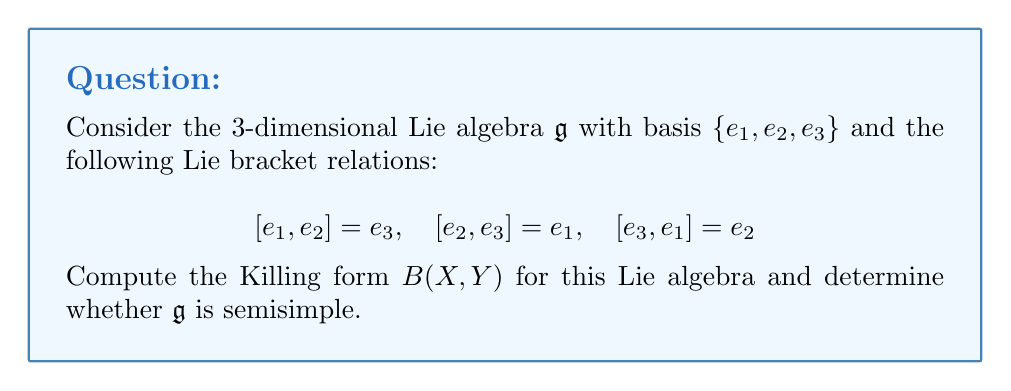Can you answer this question? To solve this problem, we'll follow these steps:

1) Recall that the Killing form is defined as $B(X,Y) = \text{tr}(\text{ad}_X \circ \text{ad}_Y)$, where $\text{ad}_X(Z) = [X,Z]$.

2) First, we need to compute the adjoint representations for each basis element:

   For $e_1$: $\text{ad}_{e_1}(e_2) = [e_1, e_2] = e_3$, $\text{ad}_{e_1}(e_3) = [e_1, e_3] = -e_2$
   
   For $e_2$: $\text{ad}_{e_2}(e_3) = [e_2, e_3] = e_1$, $\text{ad}_{e_2}(e_1) = [e_2, e_1] = -e_3$
   
   For $e_3$: $\text{ad}_{e_3}(e_1) = [e_3, e_1] = e_2$, $\text{ad}_{e_3}(e_2) = [e_3, e_2] = -e_1$

3) We can represent these as matrices:

   $$\text{ad}_{e_1} = \begin{pmatrix} 0 & 0 & 0 \\ 0 & 0 & -1 \\ 0 & 1 & 0 \end{pmatrix}$$
   
   $$\text{ad}_{e_2} = \begin{pmatrix} 0 & 0 & 1 \\ 0 & 0 & 0 \\ -1 & 0 & 0 \end{pmatrix}$$
   
   $$\text{ad}_{e_3} = \begin{pmatrix} 0 & -1 & 0 \\ 1 & 0 & 0 \\ 0 & 0 & 0 \end{pmatrix}$$

4) Now, we compute $B(e_i, e_j)$ for all $i,j \in \{1,2,3\}$:

   $B(e_1, e_1) = \text{tr}(\text{ad}_{e_1} \circ \text{ad}_{e_1}) = -2$
   
   $B(e_2, e_2) = \text{tr}(\text{ad}_{e_2} \circ \text{ad}_{e_2}) = -2$
   
   $B(e_3, e_3) = \text{tr}(\text{ad}_{e_3} \circ \text{ad}_{e_3}) = -2$
   
   $B(e_1, e_2) = B(e_2, e_1) = \text{tr}(\text{ad}_{e_1} \circ \text{ad}_{e_2}) = 0$
   
   $B(e_1, e_3) = B(e_3, e_1) = \text{tr}(\text{ad}_{e_1} \circ \text{ad}_{e_3}) = 0$
   
   $B(e_2, e_3) = B(e_3, e_2) = \text{tr}(\text{ad}_{e_2} \circ \text{ad}_{e_3}) = 0$

5) Therefore, the Killing form can be represented as the matrix:

   $$B = \begin{pmatrix} -2 & 0 & 0 \\ 0 & -2 & 0 \\ 0 & 0 & -2 \end{pmatrix}$$

6) To determine if $\mathfrak{g}$ is semisimple, we need to check if the Killing form is non-degenerate. A Lie algebra is semisimple if and only if its Killing form is non-degenerate.

7) The determinant of $B$ is $(-2)^3 = -8 \neq 0$, so $B$ is non-degenerate.

Therefore, $\mathfrak{g}$ is semisimple.
Answer: The Killing form for the given Lie algebra is:

$$B = \begin{pmatrix} -2 & 0 & 0 \\ 0 & -2 & 0 \\ 0 & 0 & -2 \end{pmatrix}$$

And $\mathfrak{g}$ is semisimple because the Killing form is non-degenerate. 